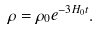Convert formula to latex. <formula><loc_0><loc_0><loc_500><loc_500>\rho = \rho _ { 0 } e ^ { - 3 H _ { 0 } t } .</formula> 